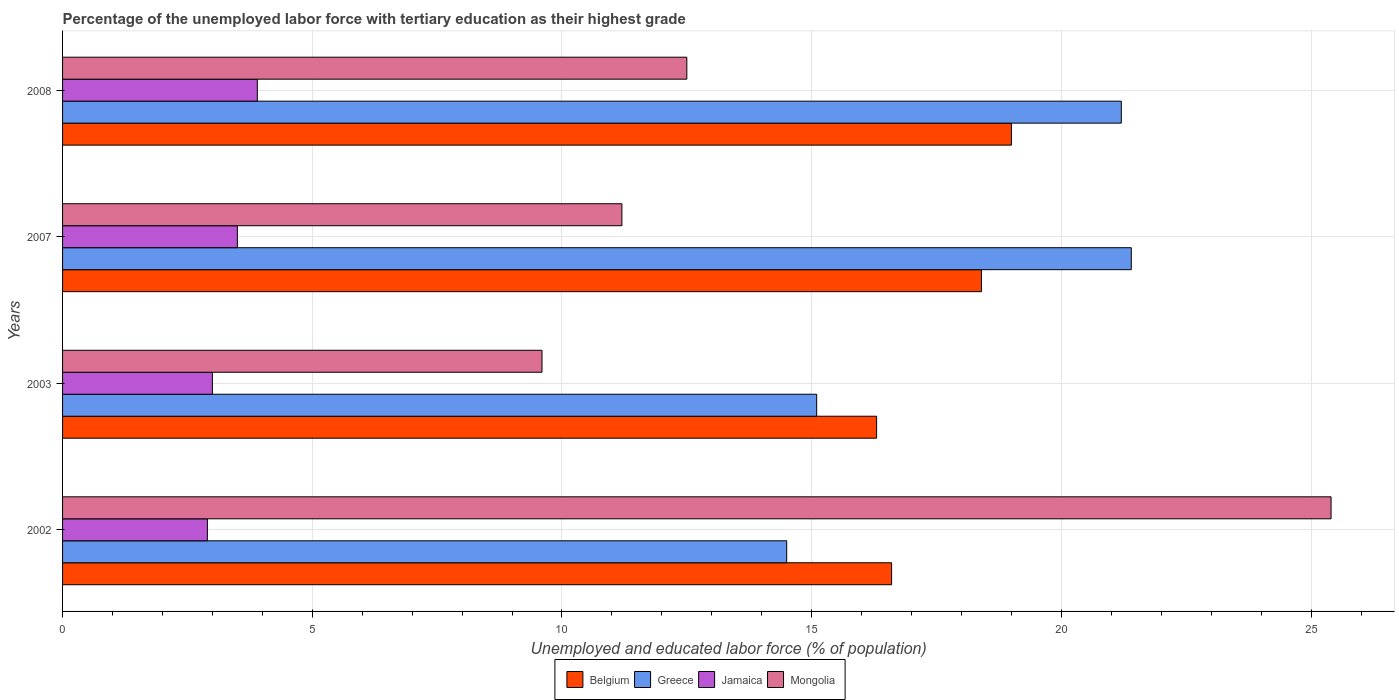Are the number of bars per tick equal to the number of legend labels?
Make the answer very short. Yes. How many bars are there on the 3rd tick from the bottom?
Provide a succinct answer. 4. What is the percentage of the unemployed labor force with tertiary education in Mongolia in 2008?
Keep it short and to the point. 12.5. Across all years, what is the maximum percentage of the unemployed labor force with tertiary education in Mongolia?
Offer a very short reply. 25.4. Across all years, what is the minimum percentage of the unemployed labor force with tertiary education in Belgium?
Your response must be concise. 16.3. In which year was the percentage of the unemployed labor force with tertiary education in Mongolia maximum?
Provide a succinct answer. 2002. In which year was the percentage of the unemployed labor force with tertiary education in Greece minimum?
Provide a succinct answer. 2002. What is the total percentage of the unemployed labor force with tertiary education in Mongolia in the graph?
Offer a very short reply. 58.7. What is the difference between the percentage of the unemployed labor force with tertiary education in Mongolia in 2002 and that in 2008?
Make the answer very short. 12.9. What is the difference between the percentage of the unemployed labor force with tertiary education in Greece in 2008 and the percentage of the unemployed labor force with tertiary education in Mongolia in 2002?
Give a very brief answer. -4.2. What is the average percentage of the unemployed labor force with tertiary education in Jamaica per year?
Offer a very short reply. 3.33. In the year 2003, what is the difference between the percentage of the unemployed labor force with tertiary education in Greece and percentage of the unemployed labor force with tertiary education in Belgium?
Provide a short and direct response. -1.2. What is the ratio of the percentage of the unemployed labor force with tertiary education in Mongolia in 2007 to that in 2008?
Offer a terse response. 0.9. What is the difference between the highest and the second highest percentage of the unemployed labor force with tertiary education in Mongolia?
Ensure brevity in your answer.  12.9. What is the difference between the highest and the lowest percentage of the unemployed labor force with tertiary education in Greece?
Provide a succinct answer. 6.9. In how many years, is the percentage of the unemployed labor force with tertiary education in Jamaica greater than the average percentage of the unemployed labor force with tertiary education in Jamaica taken over all years?
Provide a succinct answer. 2. Is the sum of the percentage of the unemployed labor force with tertiary education in Belgium in 2002 and 2007 greater than the maximum percentage of the unemployed labor force with tertiary education in Mongolia across all years?
Provide a succinct answer. Yes. What does the 3rd bar from the bottom in 2002 represents?
Your answer should be very brief. Jamaica. How many bars are there?
Your answer should be very brief. 16. Are all the bars in the graph horizontal?
Provide a short and direct response. Yes. How many years are there in the graph?
Ensure brevity in your answer.  4. What is the difference between two consecutive major ticks on the X-axis?
Offer a terse response. 5. Are the values on the major ticks of X-axis written in scientific E-notation?
Your response must be concise. No. Where does the legend appear in the graph?
Offer a very short reply. Bottom center. How are the legend labels stacked?
Provide a succinct answer. Horizontal. What is the title of the graph?
Provide a short and direct response. Percentage of the unemployed labor force with tertiary education as their highest grade. Does "France" appear as one of the legend labels in the graph?
Provide a succinct answer. No. What is the label or title of the X-axis?
Make the answer very short. Unemployed and educated labor force (% of population). What is the Unemployed and educated labor force (% of population) of Belgium in 2002?
Offer a very short reply. 16.6. What is the Unemployed and educated labor force (% of population) in Jamaica in 2002?
Offer a terse response. 2.9. What is the Unemployed and educated labor force (% of population) of Mongolia in 2002?
Provide a short and direct response. 25.4. What is the Unemployed and educated labor force (% of population) of Belgium in 2003?
Keep it short and to the point. 16.3. What is the Unemployed and educated labor force (% of population) in Greece in 2003?
Offer a terse response. 15.1. What is the Unemployed and educated labor force (% of population) in Mongolia in 2003?
Your answer should be compact. 9.6. What is the Unemployed and educated labor force (% of population) in Belgium in 2007?
Your answer should be very brief. 18.4. What is the Unemployed and educated labor force (% of population) in Greece in 2007?
Make the answer very short. 21.4. What is the Unemployed and educated labor force (% of population) in Jamaica in 2007?
Offer a terse response. 3.5. What is the Unemployed and educated labor force (% of population) of Mongolia in 2007?
Your answer should be compact. 11.2. What is the Unemployed and educated labor force (% of population) in Greece in 2008?
Your answer should be very brief. 21.2. What is the Unemployed and educated labor force (% of population) of Jamaica in 2008?
Your response must be concise. 3.9. Across all years, what is the maximum Unemployed and educated labor force (% of population) in Belgium?
Provide a succinct answer. 19. Across all years, what is the maximum Unemployed and educated labor force (% of population) in Greece?
Offer a very short reply. 21.4. Across all years, what is the maximum Unemployed and educated labor force (% of population) of Jamaica?
Ensure brevity in your answer.  3.9. Across all years, what is the maximum Unemployed and educated labor force (% of population) of Mongolia?
Offer a very short reply. 25.4. Across all years, what is the minimum Unemployed and educated labor force (% of population) of Belgium?
Give a very brief answer. 16.3. Across all years, what is the minimum Unemployed and educated labor force (% of population) of Jamaica?
Your answer should be very brief. 2.9. Across all years, what is the minimum Unemployed and educated labor force (% of population) in Mongolia?
Offer a terse response. 9.6. What is the total Unemployed and educated labor force (% of population) of Belgium in the graph?
Provide a succinct answer. 70.3. What is the total Unemployed and educated labor force (% of population) of Greece in the graph?
Offer a very short reply. 72.2. What is the total Unemployed and educated labor force (% of population) in Jamaica in the graph?
Offer a terse response. 13.3. What is the total Unemployed and educated labor force (% of population) of Mongolia in the graph?
Provide a short and direct response. 58.7. What is the difference between the Unemployed and educated labor force (% of population) of Belgium in 2002 and that in 2003?
Provide a short and direct response. 0.3. What is the difference between the Unemployed and educated labor force (% of population) of Greece in 2002 and that in 2003?
Your response must be concise. -0.6. What is the difference between the Unemployed and educated labor force (% of population) in Belgium in 2002 and that in 2007?
Make the answer very short. -1.8. What is the difference between the Unemployed and educated labor force (% of population) of Greece in 2002 and that in 2007?
Your answer should be very brief. -6.9. What is the difference between the Unemployed and educated labor force (% of population) of Jamaica in 2002 and that in 2008?
Your response must be concise. -1. What is the difference between the Unemployed and educated labor force (% of population) in Belgium in 2003 and that in 2007?
Your answer should be very brief. -2.1. What is the difference between the Unemployed and educated labor force (% of population) in Greece in 2003 and that in 2007?
Your response must be concise. -6.3. What is the difference between the Unemployed and educated labor force (% of population) of Mongolia in 2003 and that in 2007?
Offer a very short reply. -1.6. What is the difference between the Unemployed and educated labor force (% of population) of Belgium in 2003 and that in 2008?
Give a very brief answer. -2.7. What is the difference between the Unemployed and educated labor force (% of population) in Greece in 2003 and that in 2008?
Your response must be concise. -6.1. What is the difference between the Unemployed and educated labor force (% of population) in Mongolia in 2003 and that in 2008?
Provide a short and direct response. -2.9. What is the difference between the Unemployed and educated labor force (% of population) in Greece in 2007 and that in 2008?
Your answer should be compact. 0.2. What is the difference between the Unemployed and educated labor force (% of population) in Jamaica in 2007 and that in 2008?
Your answer should be compact. -0.4. What is the difference between the Unemployed and educated labor force (% of population) in Belgium in 2002 and the Unemployed and educated labor force (% of population) in Jamaica in 2003?
Give a very brief answer. 13.6. What is the difference between the Unemployed and educated labor force (% of population) of Belgium in 2002 and the Unemployed and educated labor force (% of population) of Mongolia in 2003?
Keep it short and to the point. 7. What is the difference between the Unemployed and educated labor force (% of population) in Greece in 2002 and the Unemployed and educated labor force (% of population) in Mongolia in 2003?
Provide a short and direct response. 4.9. What is the difference between the Unemployed and educated labor force (% of population) of Belgium in 2002 and the Unemployed and educated labor force (% of population) of Mongolia in 2007?
Your answer should be very brief. 5.4. What is the difference between the Unemployed and educated labor force (% of population) in Greece in 2002 and the Unemployed and educated labor force (% of population) in Mongolia in 2007?
Your answer should be compact. 3.3. What is the difference between the Unemployed and educated labor force (% of population) of Belgium in 2002 and the Unemployed and educated labor force (% of population) of Greece in 2008?
Make the answer very short. -4.6. What is the difference between the Unemployed and educated labor force (% of population) in Belgium in 2002 and the Unemployed and educated labor force (% of population) in Mongolia in 2008?
Provide a short and direct response. 4.1. What is the difference between the Unemployed and educated labor force (% of population) in Greece in 2002 and the Unemployed and educated labor force (% of population) in Mongolia in 2008?
Make the answer very short. 2. What is the difference between the Unemployed and educated labor force (% of population) in Jamaica in 2002 and the Unemployed and educated labor force (% of population) in Mongolia in 2008?
Keep it short and to the point. -9.6. What is the difference between the Unemployed and educated labor force (% of population) of Belgium in 2003 and the Unemployed and educated labor force (% of population) of Greece in 2007?
Your response must be concise. -5.1. What is the difference between the Unemployed and educated labor force (% of population) in Belgium in 2003 and the Unemployed and educated labor force (% of population) in Mongolia in 2007?
Provide a succinct answer. 5.1. What is the difference between the Unemployed and educated labor force (% of population) of Greece in 2003 and the Unemployed and educated labor force (% of population) of Mongolia in 2007?
Offer a terse response. 3.9. What is the difference between the Unemployed and educated labor force (% of population) of Belgium in 2003 and the Unemployed and educated labor force (% of population) of Greece in 2008?
Your answer should be compact. -4.9. What is the difference between the Unemployed and educated labor force (% of population) in Belgium in 2003 and the Unemployed and educated labor force (% of population) in Mongolia in 2008?
Your answer should be very brief. 3.8. What is the difference between the Unemployed and educated labor force (% of population) in Greece in 2003 and the Unemployed and educated labor force (% of population) in Jamaica in 2008?
Keep it short and to the point. 11.2. What is the difference between the Unemployed and educated labor force (% of population) in Belgium in 2007 and the Unemployed and educated labor force (% of population) in Jamaica in 2008?
Offer a terse response. 14.5. What is the difference between the Unemployed and educated labor force (% of population) of Belgium in 2007 and the Unemployed and educated labor force (% of population) of Mongolia in 2008?
Your answer should be very brief. 5.9. What is the average Unemployed and educated labor force (% of population) of Belgium per year?
Give a very brief answer. 17.57. What is the average Unemployed and educated labor force (% of population) of Greece per year?
Your answer should be compact. 18.05. What is the average Unemployed and educated labor force (% of population) in Jamaica per year?
Provide a succinct answer. 3.33. What is the average Unemployed and educated labor force (% of population) of Mongolia per year?
Offer a very short reply. 14.68. In the year 2002, what is the difference between the Unemployed and educated labor force (% of population) of Belgium and Unemployed and educated labor force (% of population) of Greece?
Offer a very short reply. 2.1. In the year 2002, what is the difference between the Unemployed and educated labor force (% of population) in Belgium and Unemployed and educated labor force (% of population) in Jamaica?
Give a very brief answer. 13.7. In the year 2002, what is the difference between the Unemployed and educated labor force (% of population) of Belgium and Unemployed and educated labor force (% of population) of Mongolia?
Provide a short and direct response. -8.8. In the year 2002, what is the difference between the Unemployed and educated labor force (% of population) of Greece and Unemployed and educated labor force (% of population) of Jamaica?
Provide a succinct answer. 11.6. In the year 2002, what is the difference between the Unemployed and educated labor force (% of population) in Jamaica and Unemployed and educated labor force (% of population) in Mongolia?
Make the answer very short. -22.5. In the year 2003, what is the difference between the Unemployed and educated labor force (% of population) in Belgium and Unemployed and educated labor force (% of population) in Greece?
Offer a terse response. 1.2. In the year 2003, what is the difference between the Unemployed and educated labor force (% of population) of Greece and Unemployed and educated labor force (% of population) of Jamaica?
Give a very brief answer. 12.1. In the year 2003, what is the difference between the Unemployed and educated labor force (% of population) in Greece and Unemployed and educated labor force (% of population) in Mongolia?
Keep it short and to the point. 5.5. In the year 2003, what is the difference between the Unemployed and educated labor force (% of population) of Jamaica and Unemployed and educated labor force (% of population) of Mongolia?
Make the answer very short. -6.6. In the year 2007, what is the difference between the Unemployed and educated labor force (% of population) of Belgium and Unemployed and educated labor force (% of population) of Greece?
Offer a very short reply. -3. In the year 2007, what is the difference between the Unemployed and educated labor force (% of population) in Belgium and Unemployed and educated labor force (% of population) in Mongolia?
Your answer should be very brief. 7.2. In the year 2007, what is the difference between the Unemployed and educated labor force (% of population) in Greece and Unemployed and educated labor force (% of population) in Mongolia?
Offer a terse response. 10.2. In the year 2007, what is the difference between the Unemployed and educated labor force (% of population) in Jamaica and Unemployed and educated labor force (% of population) in Mongolia?
Give a very brief answer. -7.7. In the year 2008, what is the difference between the Unemployed and educated labor force (% of population) in Belgium and Unemployed and educated labor force (% of population) in Jamaica?
Offer a terse response. 15.1. In the year 2008, what is the difference between the Unemployed and educated labor force (% of population) of Belgium and Unemployed and educated labor force (% of population) of Mongolia?
Make the answer very short. 6.5. In the year 2008, what is the difference between the Unemployed and educated labor force (% of population) of Greece and Unemployed and educated labor force (% of population) of Jamaica?
Ensure brevity in your answer.  17.3. In the year 2008, what is the difference between the Unemployed and educated labor force (% of population) of Greece and Unemployed and educated labor force (% of population) of Mongolia?
Give a very brief answer. 8.7. In the year 2008, what is the difference between the Unemployed and educated labor force (% of population) in Jamaica and Unemployed and educated labor force (% of population) in Mongolia?
Your answer should be compact. -8.6. What is the ratio of the Unemployed and educated labor force (% of population) of Belgium in 2002 to that in 2003?
Provide a succinct answer. 1.02. What is the ratio of the Unemployed and educated labor force (% of population) of Greece in 2002 to that in 2003?
Provide a short and direct response. 0.96. What is the ratio of the Unemployed and educated labor force (% of population) in Jamaica in 2002 to that in 2003?
Offer a terse response. 0.97. What is the ratio of the Unemployed and educated labor force (% of population) of Mongolia in 2002 to that in 2003?
Give a very brief answer. 2.65. What is the ratio of the Unemployed and educated labor force (% of population) of Belgium in 2002 to that in 2007?
Provide a succinct answer. 0.9. What is the ratio of the Unemployed and educated labor force (% of population) of Greece in 2002 to that in 2007?
Offer a terse response. 0.68. What is the ratio of the Unemployed and educated labor force (% of population) in Jamaica in 2002 to that in 2007?
Your answer should be compact. 0.83. What is the ratio of the Unemployed and educated labor force (% of population) of Mongolia in 2002 to that in 2007?
Your response must be concise. 2.27. What is the ratio of the Unemployed and educated labor force (% of population) of Belgium in 2002 to that in 2008?
Your response must be concise. 0.87. What is the ratio of the Unemployed and educated labor force (% of population) in Greece in 2002 to that in 2008?
Provide a short and direct response. 0.68. What is the ratio of the Unemployed and educated labor force (% of population) in Jamaica in 2002 to that in 2008?
Provide a succinct answer. 0.74. What is the ratio of the Unemployed and educated labor force (% of population) in Mongolia in 2002 to that in 2008?
Offer a terse response. 2.03. What is the ratio of the Unemployed and educated labor force (% of population) in Belgium in 2003 to that in 2007?
Offer a terse response. 0.89. What is the ratio of the Unemployed and educated labor force (% of population) in Greece in 2003 to that in 2007?
Provide a short and direct response. 0.71. What is the ratio of the Unemployed and educated labor force (% of population) in Mongolia in 2003 to that in 2007?
Give a very brief answer. 0.86. What is the ratio of the Unemployed and educated labor force (% of population) in Belgium in 2003 to that in 2008?
Provide a succinct answer. 0.86. What is the ratio of the Unemployed and educated labor force (% of population) of Greece in 2003 to that in 2008?
Provide a short and direct response. 0.71. What is the ratio of the Unemployed and educated labor force (% of population) in Jamaica in 2003 to that in 2008?
Provide a short and direct response. 0.77. What is the ratio of the Unemployed and educated labor force (% of population) of Mongolia in 2003 to that in 2008?
Offer a terse response. 0.77. What is the ratio of the Unemployed and educated labor force (% of population) in Belgium in 2007 to that in 2008?
Provide a succinct answer. 0.97. What is the ratio of the Unemployed and educated labor force (% of population) of Greece in 2007 to that in 2008?
Provide a succinct answer. 1.01. What is the ratio of the Unemployed and educated labor force (% of population) of Jamaica in 2007 to that in 2008?
Give a very brief answer. 0.9. What is the ratio of the Unemployed and educated labor force (% of population) of Mongolia in 2007 to that in 2008?
Offer a very short reply. 0.9. What is the difference between the highest and the second highest Unemployed and educated labor force (% of population) in Greece?
Ensure brevity in your answer.  0.2. What is the difference between the highest and the second highest Unemployed and educated labor force (% of population) in Mongolia?
Your answer should be very brief. 12.9. What is the difference between the highest and the lowest Unemployed and educated labor force (% of population) of Greece?
Make the answer very short. 6.9. What is the difference between the highest and the lowest Unemployed and educated labor force (% of population) in Jamaica?
Offer a very short reply. 1. What is the difference between the highest and the lowest Unemployed and educated labor force (% of population) of Mongolia?
Make the answer very short. 15.8. 